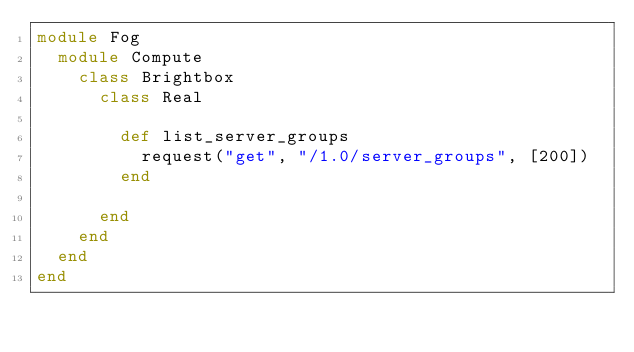Convert code to text. <code><loc_0><loc_0><loc_500><loc_500><_Ruby_>module Fog
  module Compute
    class Brightbox
      class Real

        def list_server_groups
          request("get", "/1.0/server_groups", [200])
        end

      end
    end
  end
end</code> 